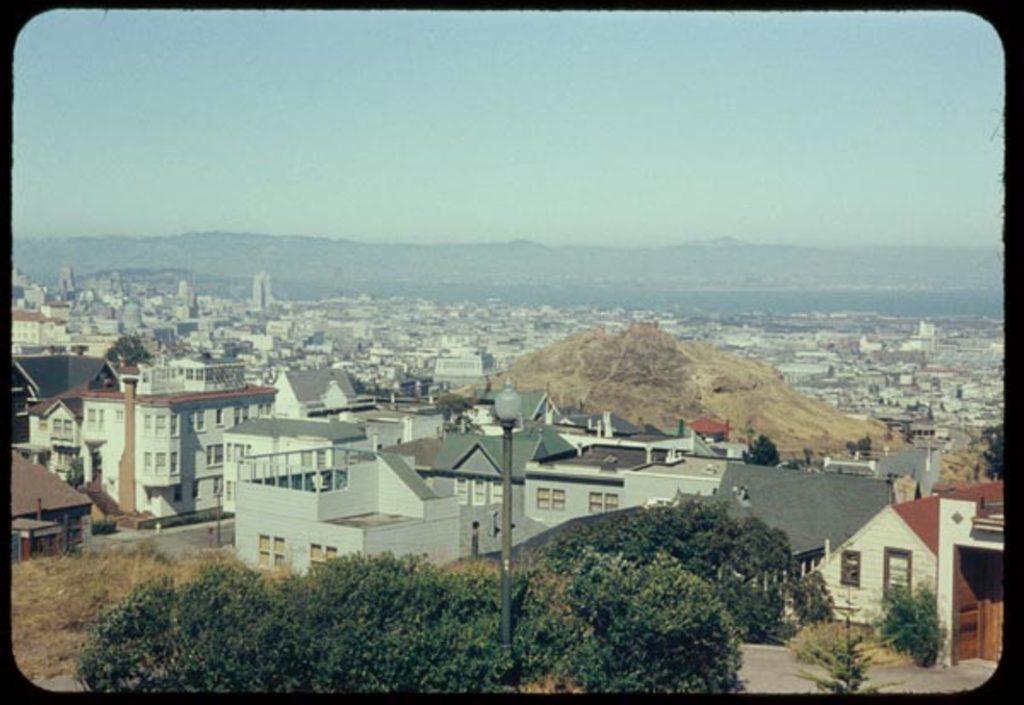Please provide a concise description of this image. This image taken outdoors. At the top of the image there is the sky. In the middle of the image there are many buildings and houses. There are a few trees and plants with leaves, stems and branches. There are many poles with street lights. 